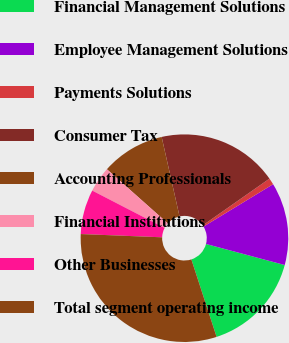<chart> <loc_0><loc_0><loc_500><loc_500><pie_chart><fcel>Financial Management Solutions<fcel>Employee Management Solutions<fcel>Payments Solutions<fcel>Consumer Tax<fcel>Accounting Professionals<fcel>Financial Institutions<fcel>Other Businesses<fcel>Total segment operating income<nl><fcel>15.83%<fcel>12.87%<fcel>1.02%<fcel>18.8%<fcel>9.91%<fcel>3.98%<fcel>6.95%<fcel>30.65%<nl></chart> 